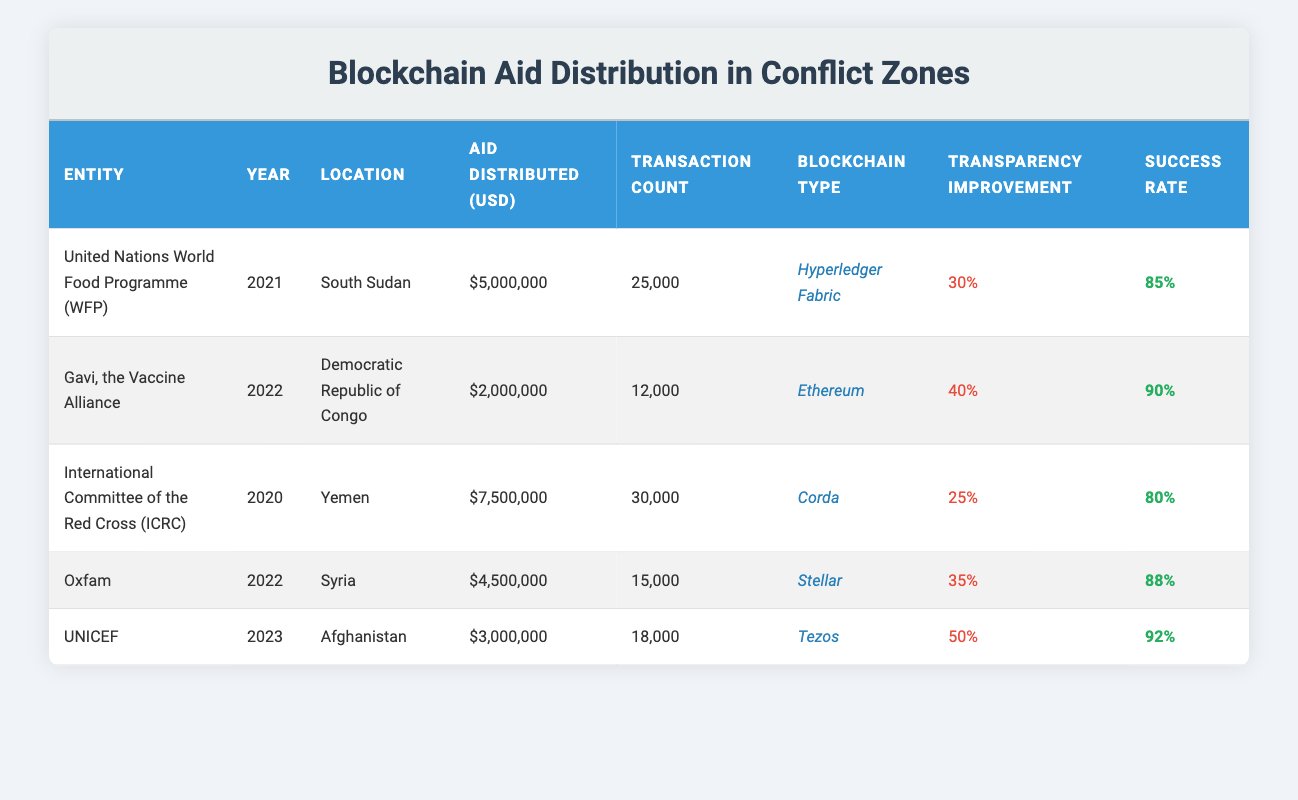What year did UNICEF distribute aid? The table indicates that UNICEF distributed aid in the year 2023.
Answer: 2023 What is the total amount of aid distributed by Gavi in USD? According to the table, Gavi distributed a total of 2,000,000 USD.
Answer: 2,000,000 USD Which blockchain type provided the highest transparency improvement? Upon reviewing the transparency improvement values, UNICEF's use of Tezos provided the highest at 50%.
Answer: Tezos How many more transactions were made by the International Committee of the Red Cross compared to Gavi? The ICRC made 30,000 transactions while Gavi made 12,000. The difference is 30,000 - 12,000 = 18,000 transactions.
Answer: 18,000 transactions Is the success rate of Oxfam higher than that of the United Nations World Food Programme? Oxfam's success rate is 88%, while WFP's success rate is 85%. Since 88% is greater than 85%, the answer is yes.
Answer: Yes What is the average aid distributed in USD by the organizations listed in the table? Adding all the aid distributed: (5,000,000 + 2,000,000 + 7,500,000 + 4,500,000 + 3,000,000) = 22,000,000 USD. There are 5 organizations, so the average is 22,000,000 / 5 = 4,400,000 USD.
Answer: 4,400,000 USD Which location had the highest aid distributed, and how much was that amount? Comparing the aid amounts, Yemen received 7,500,000 USD, which is the highest among all listed locations.
Answer: Yemen; 7,500,000 USD Did Oxfam have more aid distributed than UNICEF? Oxfam distributed 4,500,000 USD while UNICEF distributed 3,000,000 USD. Therefore, Oxfam had more aid distributed.
Answer: Yes Which organization had the lowest success rate among the ones listed? Looking at the success rates, the lowest is from the International Committee of the Red Cross with 80%.
Answer: International Committee of the Red Cross 